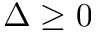Convert formula to latex. <formula><loc_0><loc_0><loc_500><loc_500>\Delta \geq 0</formula> 